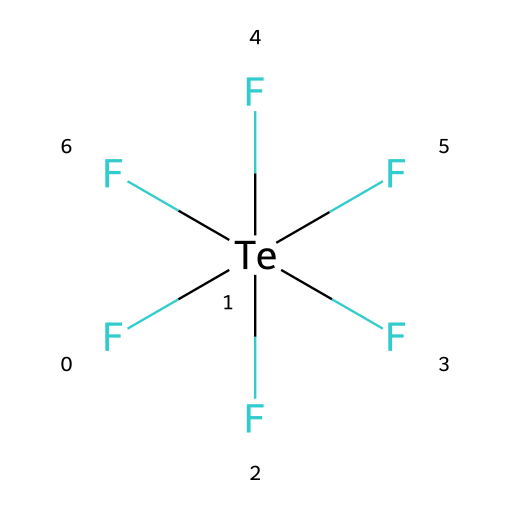What is the central atom in the chemical structure? The chemical structure shows tellurium surrounded by six fluorine atoms. Therefore, the central atom is tellurium (Te).
Answer: tellurium How many fluorine atoms are bonded to the tellurium atom? The SMILES representation indicates six instances of fluorine (F) bonded to the central tellurium atom, as detailed in the structure.
Answer: six What is the oxidation state of tellurium in this compound? In tellurium hexafluoride, the tellurium atom is typically assigned an oxidation state of +6, since each F with a -1 charge results in a total of -6 for the fluorines. Therefore, Te must be +6 to balance the charge.
Answer: +6 Is this compound considered hypervalent? Hypervalent compounds are those where the central atom can accommodate more than eight electrons. Tellurium hexafluoride has twelve valence electrons around tellurium, thus qualifying it as hypervalent.
Answer: yes What type of hybridization is present in tellurium hexafluoride? In tellurium hexafluoride, the bonding requires sp3d2 hybridization to accommodate six bonding pairs between the tellurium atom and the fluorine atoms.
Answer: sp3d2 What is the molecular geometry of tellurium hexafluoride? Given its sp3d2 hybridization and six bonded fluorine atoms, the molecular geometry of tellurium hexafluoride is octahedral.
Answer: octahedral 